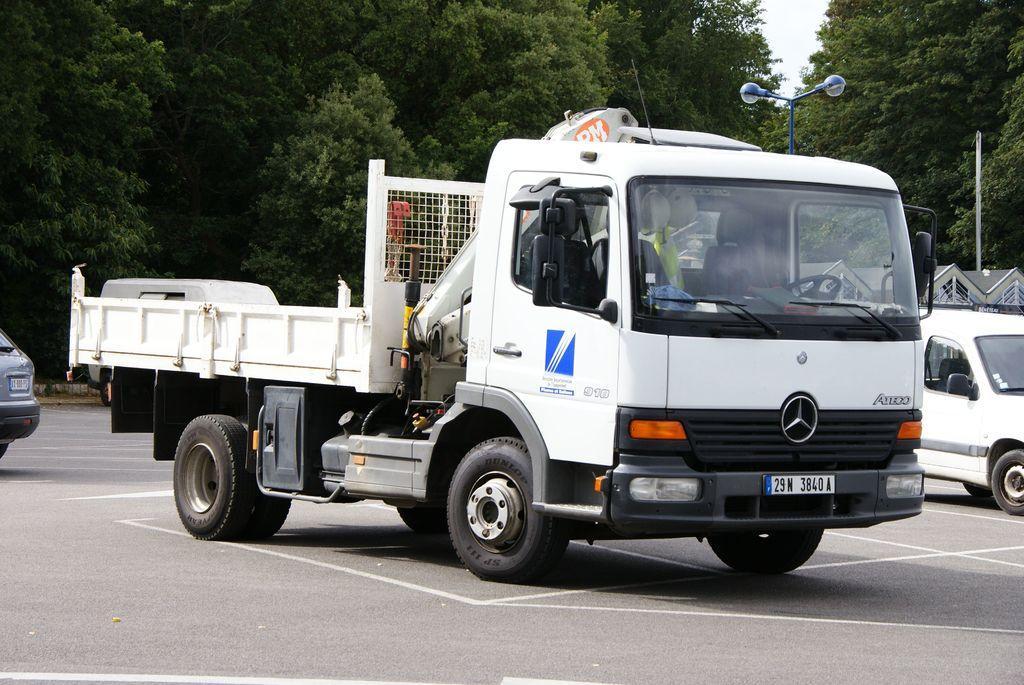Can you describe this image briefly? In the picture we can see a truck, which is white in color with a trolley on it and beside it, we can see some cars and behind it also we can see some cars and behind it we can see a pole with lights and in the background we can see trees. 